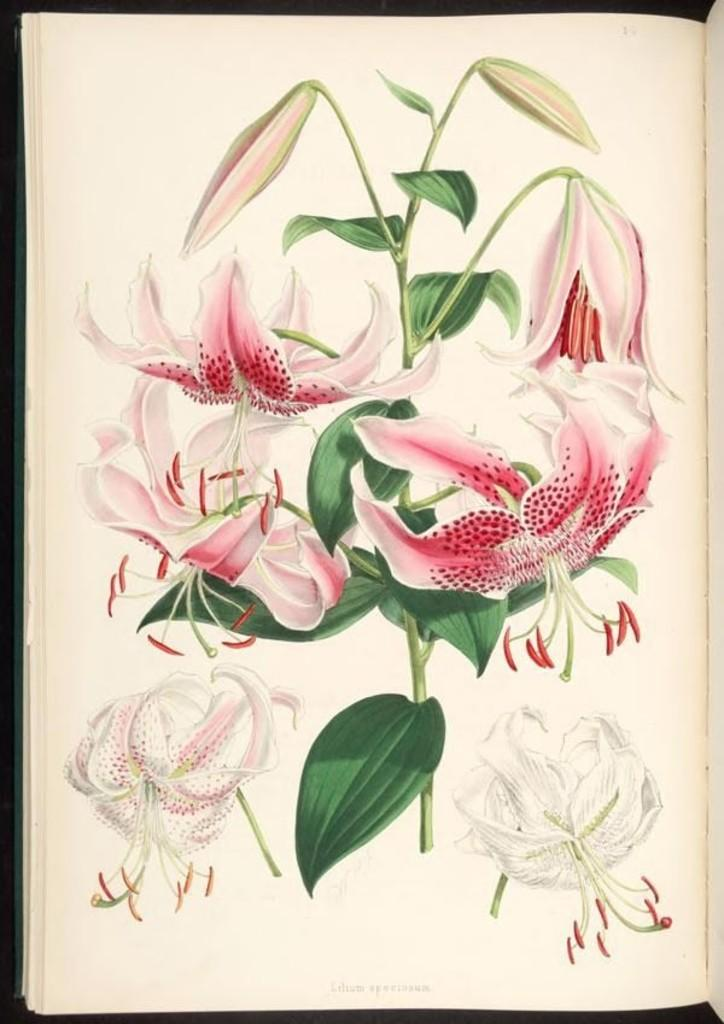What is the main subject of the image? The main subject of the image is a picture of a plant with flowers. Are there any other flower pictures in the image? Yes, there are two more flower pictures at the bottom of the image. Where are these flower pictures located? These flower pictures are on a page of a book. How many eyes can be seen on the toothbrush in the image? There is no toothbrush present in the image, so it is not possible to determine the number of eyes on it. 